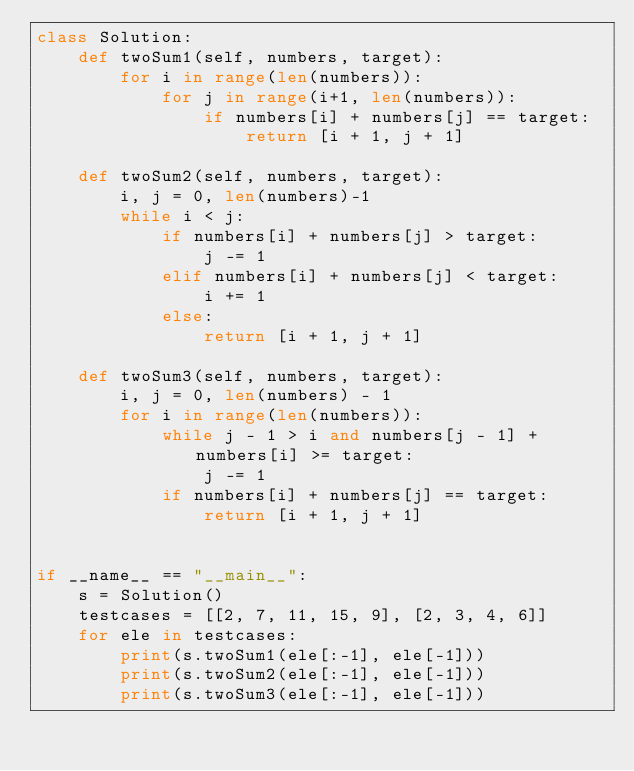<code> <loc_0><loc_0><loc_500><loc_500><_Python_>class Solution:
    def twoSum1(self, numbers, target):
        for i in range(len(numbers)):
            for j in range(i+1, len(numbers)):
                if numbers[i] + numbers[j] == target:
                    return [i + 1, j + 1]

    def twoSum2(self, numbers, target):
        i, j = 0, len(numbers)-1
        while i < j:
            if numbers[i] + numbers[j] > target:
                j -= 1
            elif numbers[i] + numbers[j] < target:
                i += 1
            else:
                return [i + 1, j + 1]

    def twoSum3(self, numbers, target):
        i, j = 0, len(numbers) - 1
        for i in range(len(numbers)):
            while j - 1 > i and numbers[j - 1] + numbers[i] >= target:
                j -= 1
            if numbers[i] + numbers[j] == target:
                return [i + 1, j + 1]


if __name__ == "__main__":
    s = Solution()
    testcases = [[2, 7, 11, 15, 9], [2, 3, 4, 6]]
    for ele in testcases:
        print(s.twoSum1(ele[:-1], ele[-1]))
        print(s.twoSum2(ele[:-1], ele[-1]))
        print(s.twoSum3(ele[:-1], ele[-1]))
</code> 